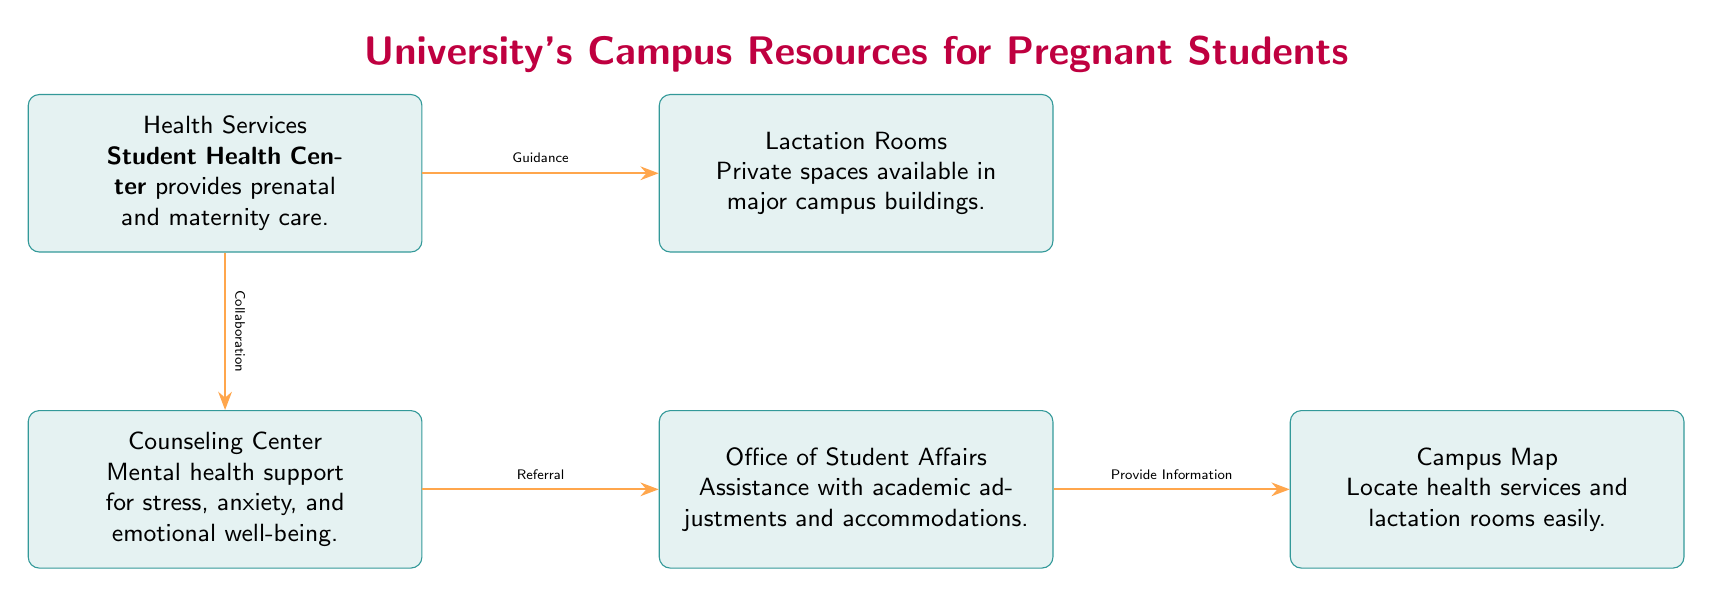What resources are available for pregnant students on campus? The diagram lists three main resources: Health Services, Counseling Center, and Lactation Rooms.
Answer: Health Services, Counseling Center, Lactation Rooms What relationship exists between Health Services and Counseling Center? The arrow between Health Services and Counseling Center indicates a 'Collaboration,' which means both services work together to support pregnant students.
Answer: Collaboration How many edges are in the diagram? The diagram has four edges connecting the nodes, which are the relationships between the different resources.
Answer: Four Which office provides assistance with academic adjustments for pregnant students? The diagram clearly identifies the Office of Student Affairs as the resource that assists with academic adjustments.
Answer: Office of Student Affairs What type of support does the Counseling Center provide? The diagram states that the Counseling Center offers mental health support specifically for stress, anxiety, and emotional well-being.
Answer: Mental health support What is the purpose of the Campus Map in relation to the other resources? The diagram shows that the Campus Map provides information regarding the locations of health services and lactation rooms, facilitating easy access for students.
Answer: Provide Information Which resource is located to the right of Health Services? According to the diagram, Lactation Rooms are positioned directly to the right of Health Services, indicating their physical proximity on campus.
Answer: Lactation Rooms What kind of care is offered by the Student Health Center? The diagram indicates that the Student Health Center provides prenatal and maternity care, which is essential for pregnant students.
Answer: Prenatal and maternity care Which two nodes are connected by the relationship ‘Referral’? The diagram shows an arrow with the label 'Referral' pointing from Counseling Center to Office of Student Affairs, indicating a connection between these two resources.
Answer: Counseling Center, Office of Student Affairs 